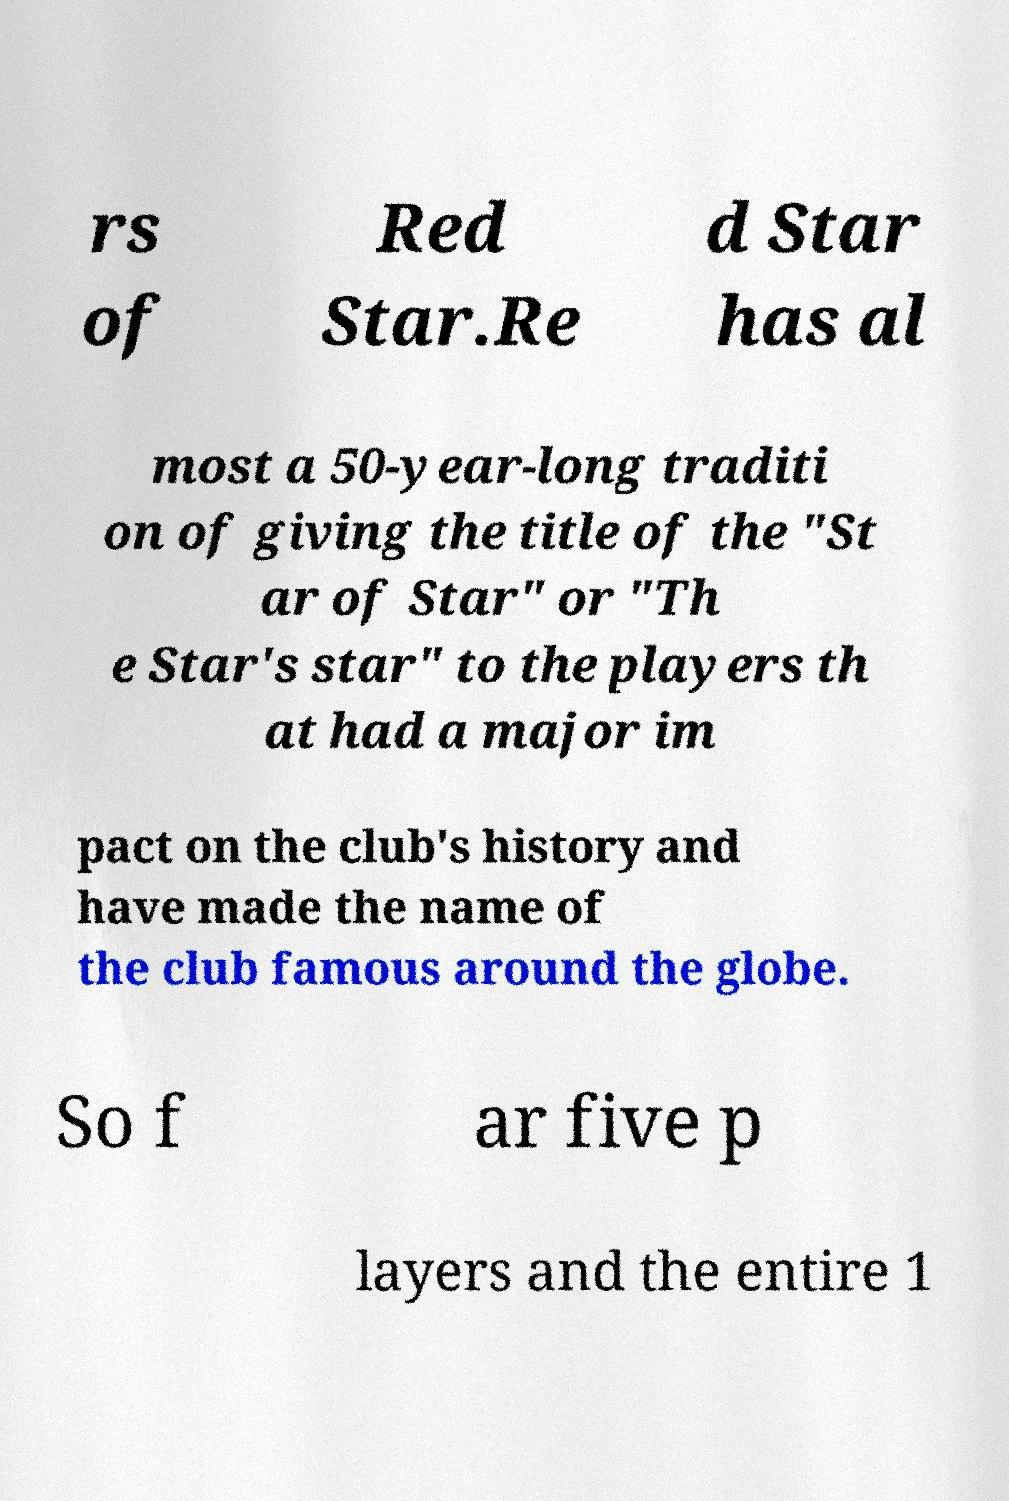Please read and relay the text visible in this image. What does it say? rs of Red Star.Re d Star has al most a 50-year-long traditi on of giving the title of the "St ar of Star" or "Th e Star's star" to the players th at had a major im pact on the club's history and have made the name of the club famous around the globe. So f ar five p layers and the entire 1 